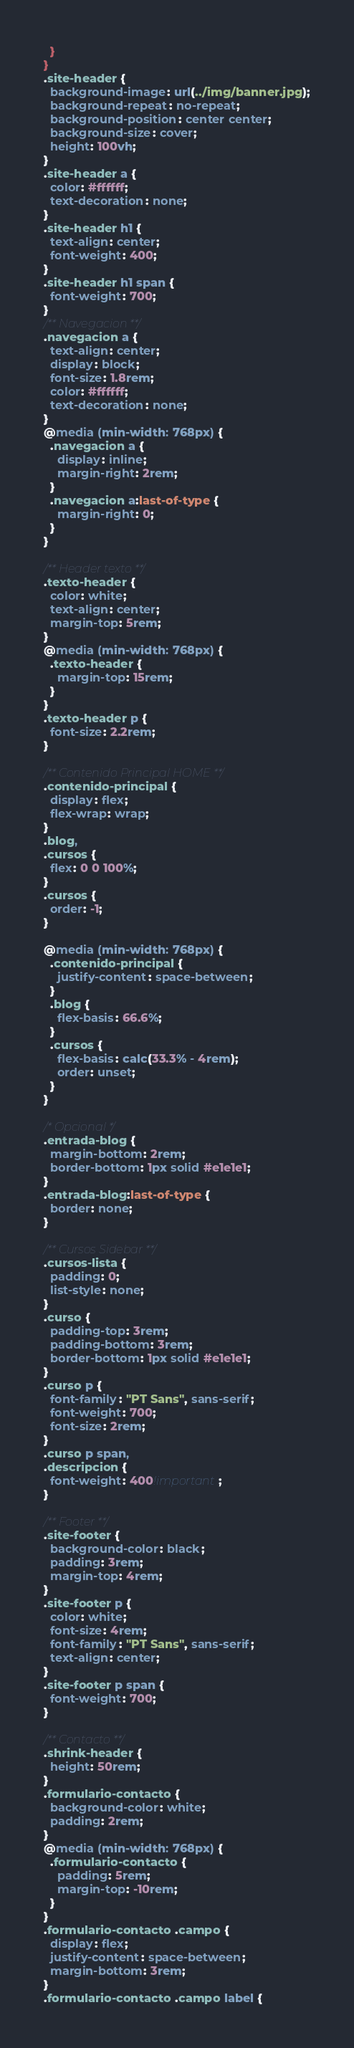Convert code to text. <code><loc_0><loc_0><loc_500><loc_500><_CSS_>  }
}
.site-header {
  background-image: url(../img/banner.jpg);
  background-repeat: no-repeat;
  background-position: center center;
  background-size: cover;
  height: 100vh;
}
.site-header a {
  color: #ffffff;
  text-decoration: none;
}
.site-header h1 {
  text-align: center;
  font-weight: 400;
}
.site-header h1 span {
  font-weight: 700;
}
/** Navegacion **/
.navegacion a {
  text-align: center;
  display: block;
  font-size: 1.8rem;
  color: #ffffff;
  text-decoration: none;
}
@media (min-width: 768px) {
  .navegacion a {
    display: inline;
    margin-right: 2rem;
  }
  .navegacion a:last-of-type {
    margin-right: 0;
  }
}

/** Header texto **/
.texto-header {
  color: white;
  text-align: center;
  margin-top: 5rem;
}
@media (min-width: 768px) {
  .texto-header {
    margin-top: 15rem;
  }
}
.texto-header p {
  font-size: 2.2rem;
}

/** Contenido Principal HOME **/
.contenido-principal {
  display: flex;
  flex-wrap: wrap;
}
.blog,
.cursos {
  flex: 0 0 100%;
}
.cursos {
  order: -1;
}

@media (min-width: 768px) {
  .contenido-principal {
    justify-content: space-between;
  }
  .blog {
    flex-basis: 66.6%;
  }
  .cursos {
    flex-basis: calc(33.3% - 4rem);
    order: unset;
  }
}

/* Opcional */
.entrada-blog {
  margin-bottom: 2rem;
  border-bottom: 1px solid #e1e1e1;
}
.entrada-blog:last-of-type {
  border: none;
}

/** Cursos Sidebar **/
.cursos-lista {
  padding: 0;
  list-style: none;
}
.curso {
  padding-top: 3rem;
  padding-bottom: 3rem;
  border-bottom: 1px solid #e1e1e1;
}
.curso p {
  font-family: "PT Sans", sans-serif;
  font-weight: 700;
  font-size: 2rem;
}
.curso p span,
.descripcion {
  font-weight: 400!important;
}

/** Footer **/
.site-footer {
  background-color: black;
  padding: 3rem;
  margin-top: 4rem;
}
.site-footer p {
  color: white;
  font-size: 4rem;
  font-family: "PT Sans", sans-serif;
  text-align: center;
}
.site-footer p span {
  font-weight: 700;
}

/** Contacto **/
.shrink-header {
  height: 50rem;
}
.formulario-contacto {
  background-color: white;
  padding: 2rem;
}
@media (min-width: 768px) { 
  .formulario-contacto {
    padding: 5rem;
    margin-top: -10rem;
  }
}
.formulario-contacto .campo {
  display: flex;
  justify-content: space-between;
  margin-bottom: 3rem;
}
.formulario-contacto .campo label {</code> 